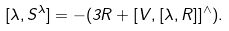Convert formula to latex. <formula><loc_0><loc_0><loc_500><loc_500>[ \lambda , S ^ { \lambda } ] = - ( 3 R + [ V , [ \lambda , R ] ] ^ { \wedge } ) .</formula> 